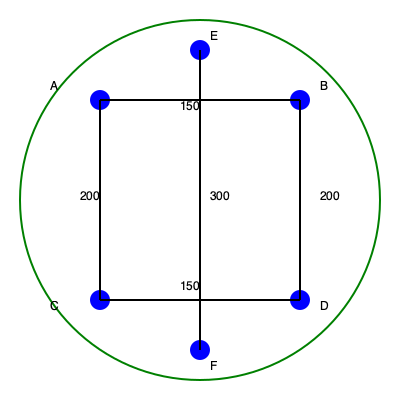Given the graph representing a golf course layout, where nodes represent key locations and edges represent potential cart paths with their respective distances (in yards), determine the minimum total distance of cart paths required to connect all locations using a minimum spanning tree. What is the total distance of the optimal cart path network? To solve this problem, we'll use Kruskal's algorithm to find the minimum spanning tree:

1) Sort all edges by weight (distance):
   AB: 150
   CD: 150
   AC: 200
   BD: 200
   EF: 300

2) Start with an empty set of edges and add edges in order of increasing weight, skipping any that would create a cycle:

   - Add AB (150)
   - Add CD (150)
   - Add AC (200)
   - Skip BD (would create a cycle)
   - Add EF (300)

3) The minimum spanning tree is now complete, connecting all nodes.

4) Calculate the total distance:
   $$ \text{Total Distance} = 150 + 150 + 200 + 300 = 800 \text{ yards} $$

Therefore, the optimal cart path network has a total distance of 800 yards.
Answer: 800 yards 